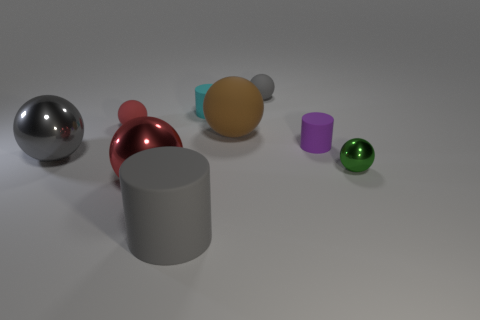Subtract all green spheres. How many spheres are left? 5 Subtract 3 spheres. How many spheres are left? 3 Subtract all large matte spheres. How many spheres are left? 5 Subtract all green cylinders. Subtract all brown balls. How many cylinders are left? 3 Subtract all cylinders. How many objects are left? 6 Add 3 tiny green metallic spheres. How many tiny green metallic spheres exist? 4 Subtract 0 yellow blocks. How many objects are left? 9 Subtract all red matte things. Subtract all red metal objects. How many objects are left? 7 Add 7 gray cylinders. How many gray cylinders are left? 8 